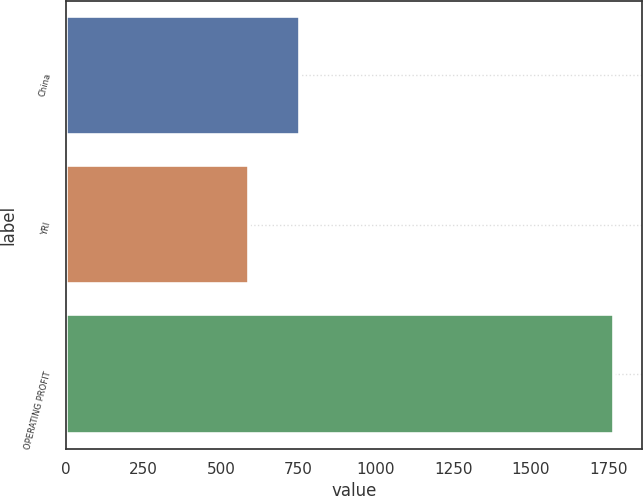<chart> <loc_0><loc_0><loc_500><loc_500><bar_chart><fcel>China<fcel>YRI<fcel>OPERATING PROFIT<nl><fcel>755<fcel>592<fcel>1769<nl></chart> 